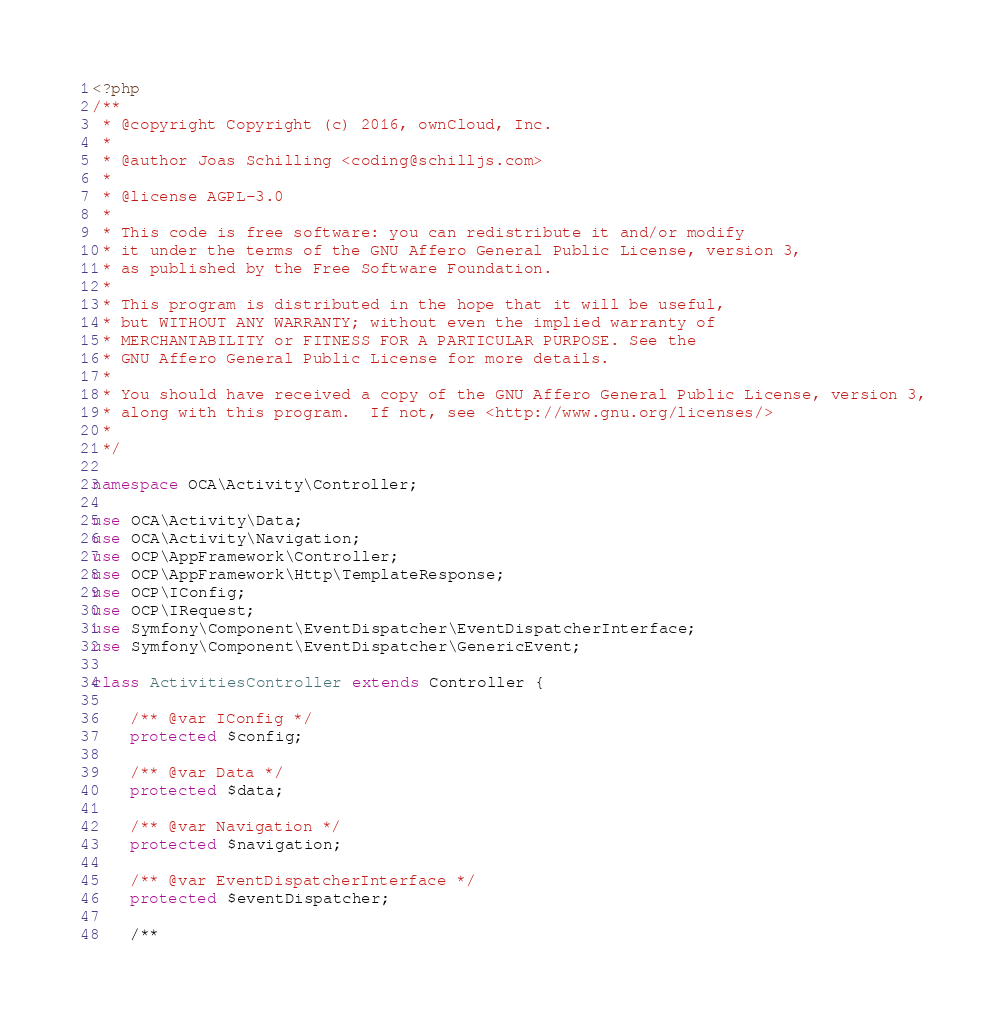<code> <loc_0><loc_0><loc_500><loc_500><_PHP_><?php
/**
 * @copyright Copyright (c) 2016, ownCloud, Inc.
 *
 * @author Joas Schilling <coding@schilljs.com>
 *
 * @license AGPL-3.0
 *
 * This code is free software: you can redistribute it and/or modify
 * it under the terms of the GNU Affero General Public License, version 3,
 * as published by the Free Software Foundation.
 *
 * This program is distributed in the hope that it will be useful,
 * but WITHOUT ANY WARRANTY; without even the implied warranty of
 * MERCHANTABILITY or FITNESS FOR A PARTICULAR PURPOSE. See the
 * GNU Affero General Public License for more details.
 *
 * You should have received a copy of the GNU Affero General Public License, version 3,
 * along with this program.  If not, see <http://www.gnu.org/licenses/>
 *
 */

namespace OCA\Activity\Controller;

use OCA\Activity\Data;
use OCA\Activity\Navigation;
use OCP\AppFramework\Controller;
use OCP\AppFramework\Http\TemplateResponse;
use OCP\IConfig;
use OCP\IRequest;
use Symfony\Component\EventDispatcher\EventDispatcherInterface;
use Symfony\Component\EventDispatcher\GenericEvent;

class ActivitiesController extends Controller {

	/** @var IConfig */
	protected $config;

	/** @var Data */
	protected $data;

	/** @var Navigation */
	protected $navigation;

	/** @var EventDispatcherInterface */
	protected $eventDispatcher;

	/**</code> 